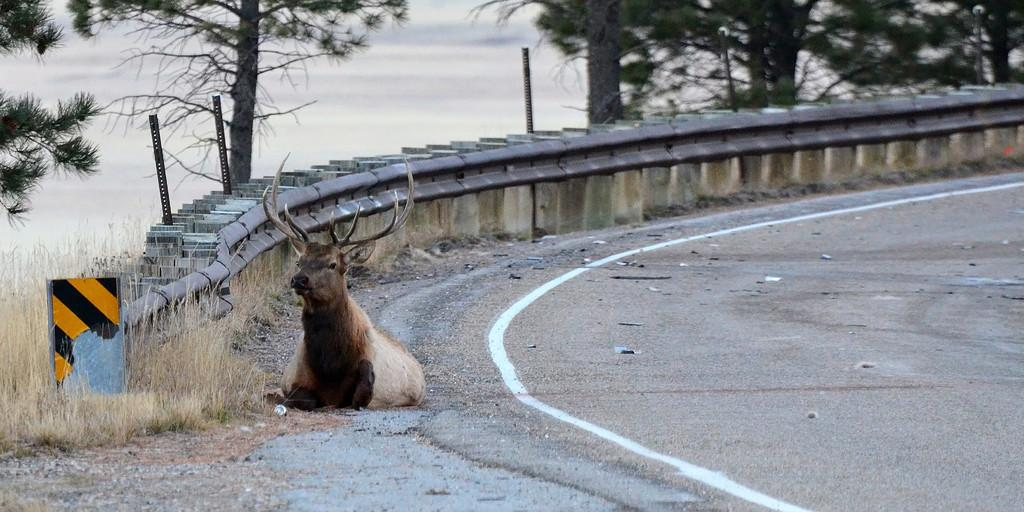What animal can be seen sitting on the road in the image? There is a deer sitting on the road in the image. What type of barrier is visible in the image? There is a railing visible in the image. What type of vegetation is present in the image? There are trees in the image. What natural element can be seen in the image? There is water visible in the image. How many servants are visible in the image? There are no servants present in the image. What type of structure can be seen in the image? There is no specific structure mentioned in the provided facts, so it cannot be determined from the image. 